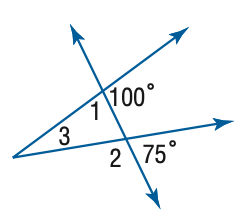Answer the mathemtical geometry problem and directly provide the correct option letter.
Question: Find the measure of \angle 1 in the figure.
Choices: A: 75 B: 80 C: 85 D: 90 B 